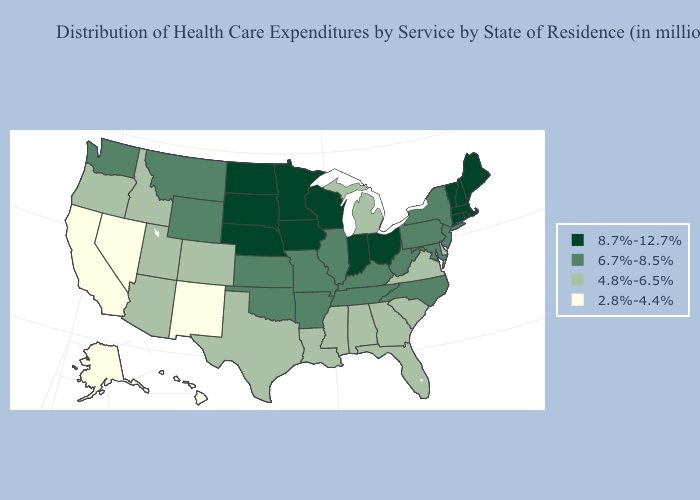What is the value of California?
Answer briefly. 2.8%-4.4%. Does North Dakota have the lowest value in the USA?
Be succinct. No. How many symbols are there in the legend?
Answer briefly. 4. Which states hav the highest value in the South?
Quick response, please. Arkansas, Kentucky, Maryland, North Carolina, Oklahoma, Tennessee, West Virginia. What is the value of Utah?
Keep it brief. 4.8%-6.5%. Among the states that border Nevada , which have the highest value?
Short answer required. Arizona, Idaho, Oregon, Utah. What is the highest value in the USA?
Keep it brief. 8.7%-12.7%. Among the states that border Connecticut , which have the lowest value?
Give a very brief answer. New York. Name the states that have a value in the range 8.7%-12.7%?
Short answer required. Connecticut, Indiana, Iowa, Maine, Massachusetts, Minnesota, Nebraska, New Hampshire, North Dakota, Ohio, Rhode Island, South Dakota, Vermont, Wisconsin. What is the highest value in the USA?
Be succinct. 8.7%-12.7%. Which states hav the highest value in the Northeast?
Answer briefly. Connecticut, Maine, Massachusetts, New Hampshire, Rhode Island, Vermont. Name the states that have a value in the range 8.7%-12.7%?
Write a very short answer. Connecticut, Indiana, Iowa, Maine, Massachusetts, Minnesota, Nebraska, New Hampshire, North Dakota, Ohio, Rhode Island, South Dakota, Vermont, Wisconsin. What is the value of Kentucky?
Short answer required. 6.7%-8.5%. What is the value of Rhode Island?
Give a very brief answer. 8.7%-12.7%. 